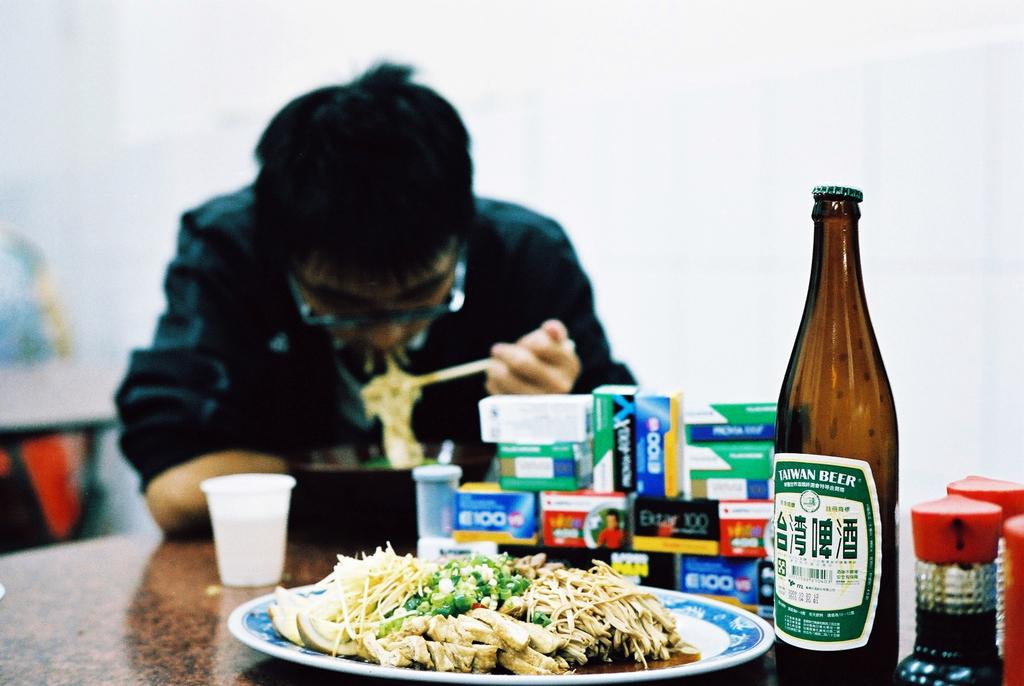<image>
Create a compact narrative representing the image presented. A bottle of Taiwan beer, food on top of a table and a Asian man sitting on the table eating noodles. 